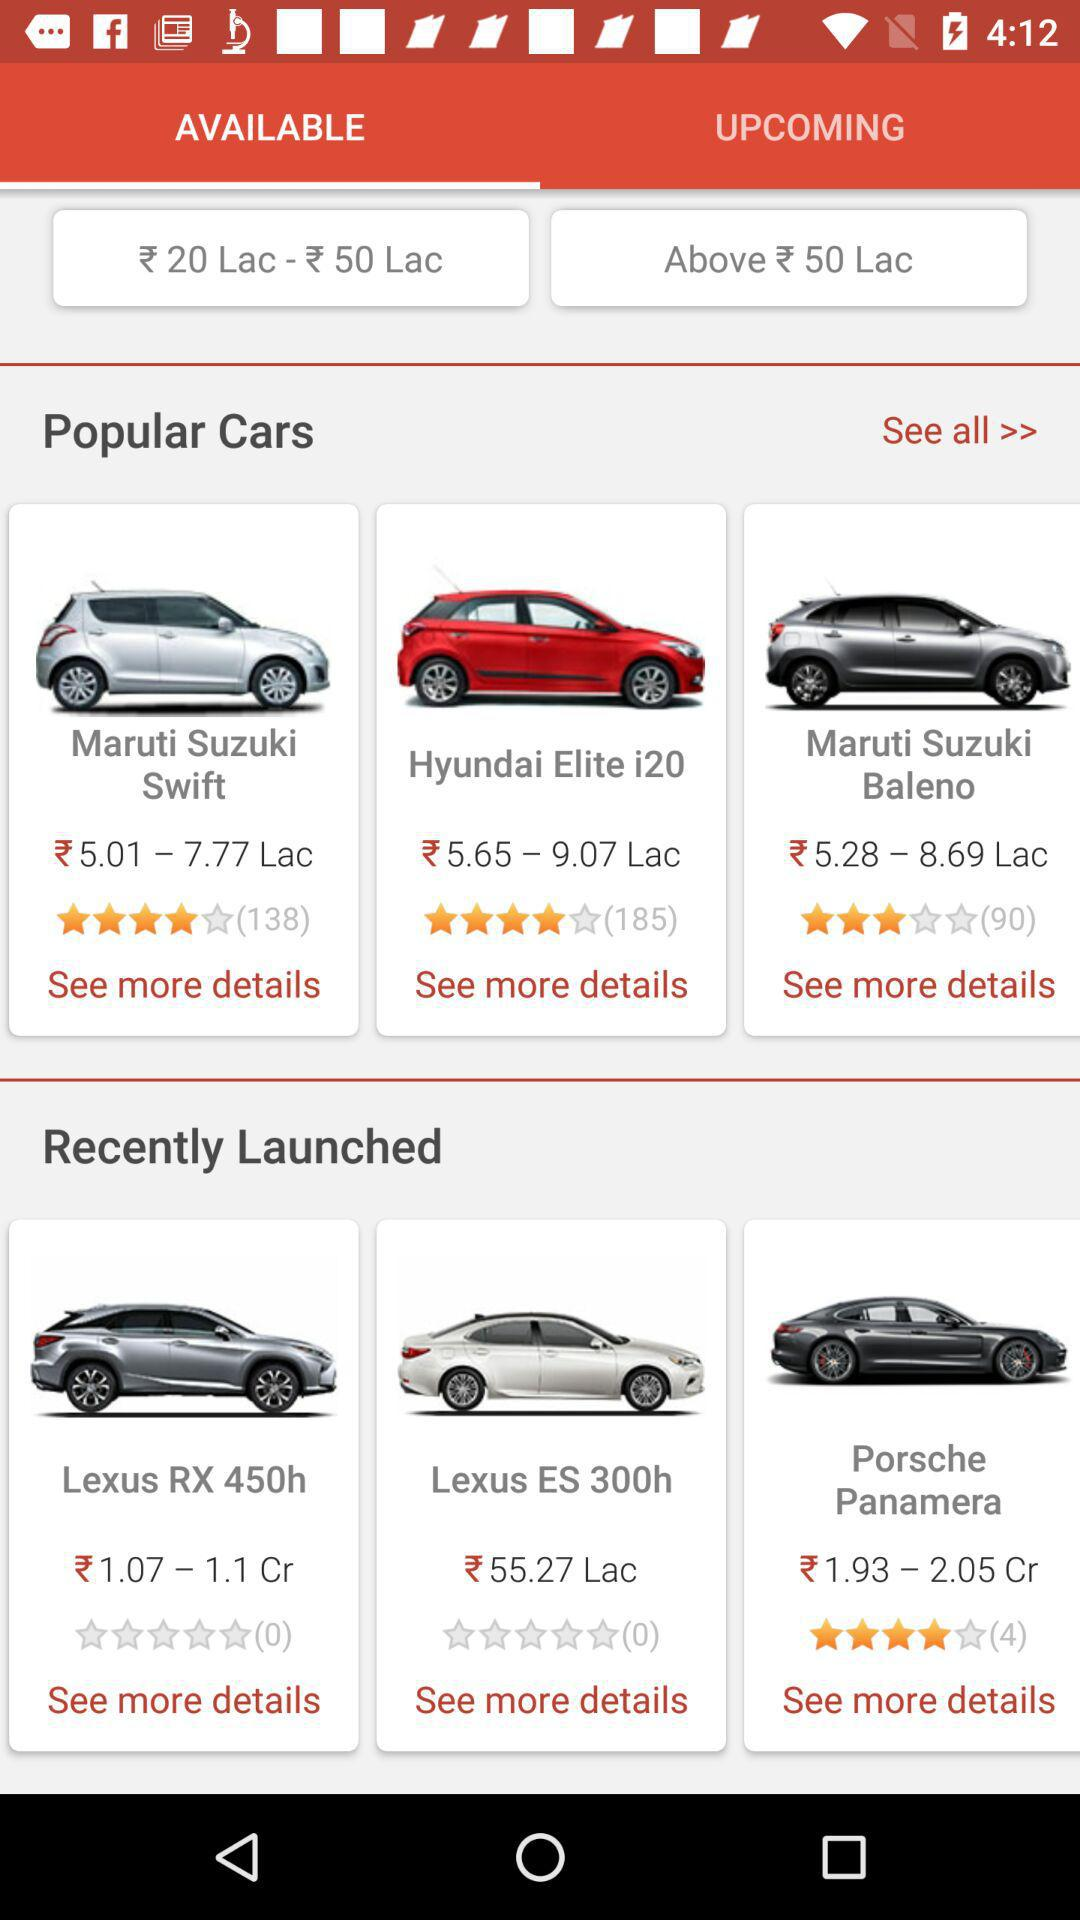How many cars are available in the 'Recently Launched' section?
Answer the question using a single word or phrase. 3 